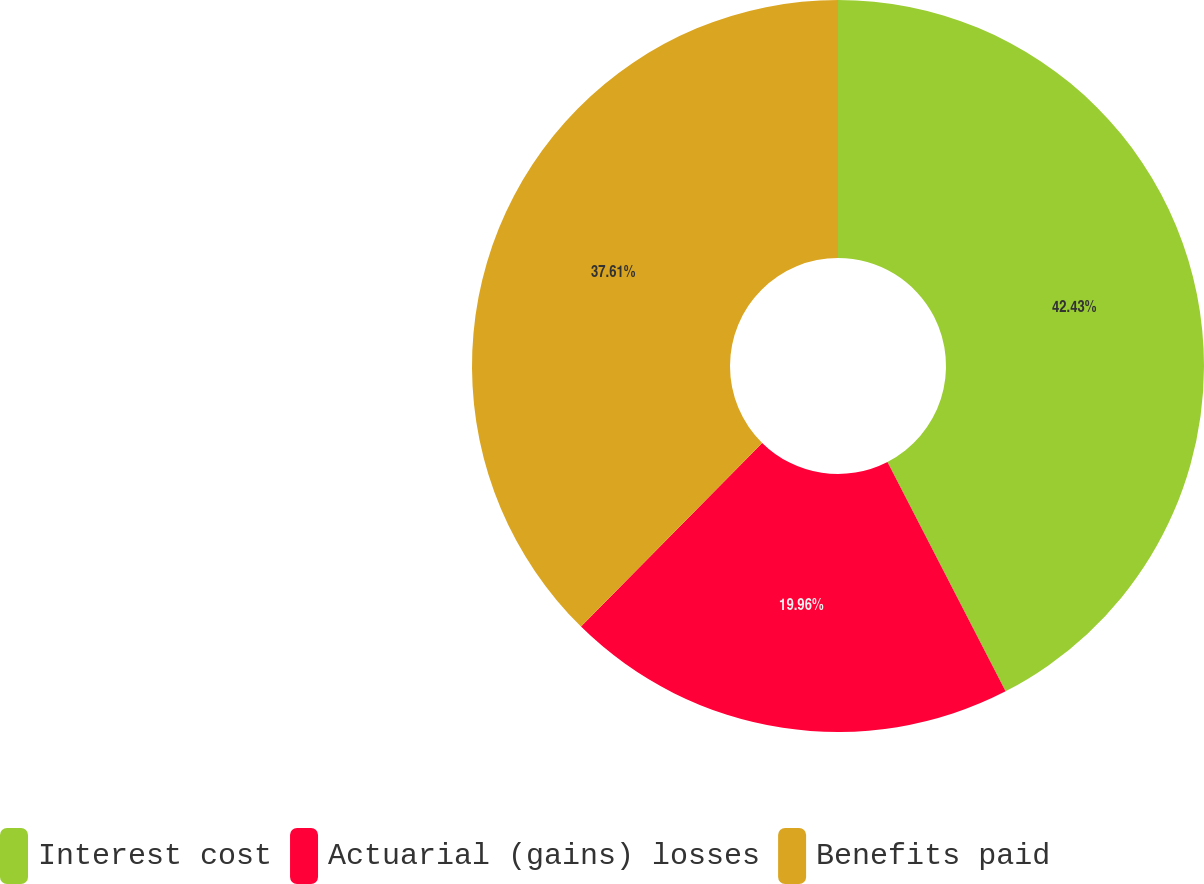Convert chart. <chart><loc_0><loc_0><loc_500><loc_500><pie_chart><fcel>Interest cost<fcel>Actuarial (gains) losses<fcel>Benefits paid<nl><fcel>42.43%<fcel>19.96%<fcel>37.61%<nl></chart> 